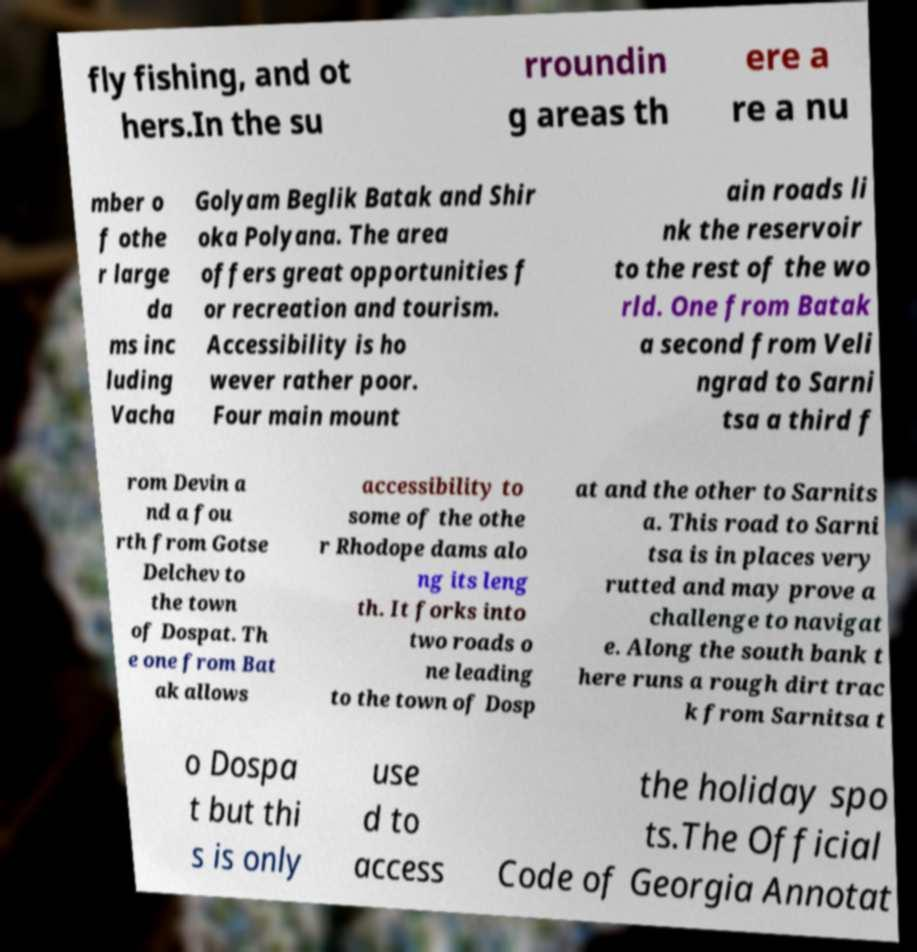Could you assist in decoding the text presented in this image and type it out clearly? fly fishing, and ot hers.In the su rroundin g areas th ere a re a nu mber o f othe r large da ms inc luding Vacha Golyam Beglik Batak and Shir oka Polyana. The area offers great opportunities f or recreation and tourism. Accessibility is ho wever rather poor. Four main mount ain roads li nk the reservoir to the rest of the wo rld. One from Batak a second from Veli ngrad to Sarni tsa a third f rom Devin a nd a fou rth from Gotse Delchev to the town of Dospat. Th e one from Bat ak allows accessibility to some of the othe r Rhodope dams alo ng its leng th. It forks into two roads o ne leading to the town of Dosp at and the other to Sarnits a. This road to Sarni tsa is in places very rutted and may prove a challenge to navigat e. Along the south bank t here runs a rough dirt trac k from Sarnitsa t o Dospa t but thi s is only use d to access the holiday spo ts.The Official Code of Georgia Annotat 